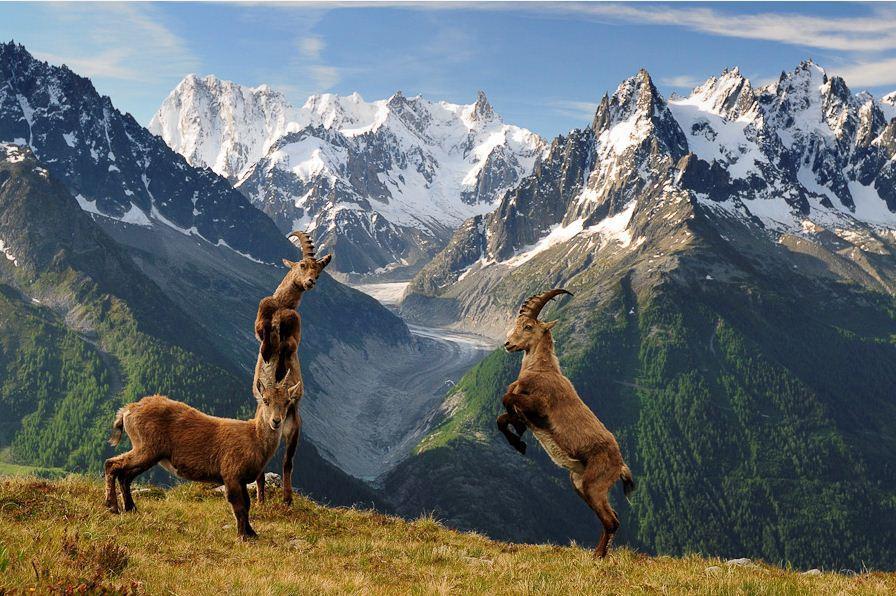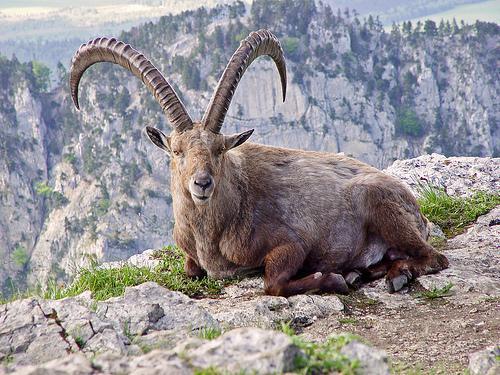The first image is the image on the left, the second image is the image on the right. For the images displayed, is the sentence "One of the images shows a horned mountain goat laying in the grass with mountains behind it." factually correct? Answer yes or no. Yes. The first image is the image on the left, the second image is the image on the right. For the images shown, is this caption "An image shows exactly one long-horned animal, which is posed with legs tucked underneath." true? Answer yes or no. Yes. 